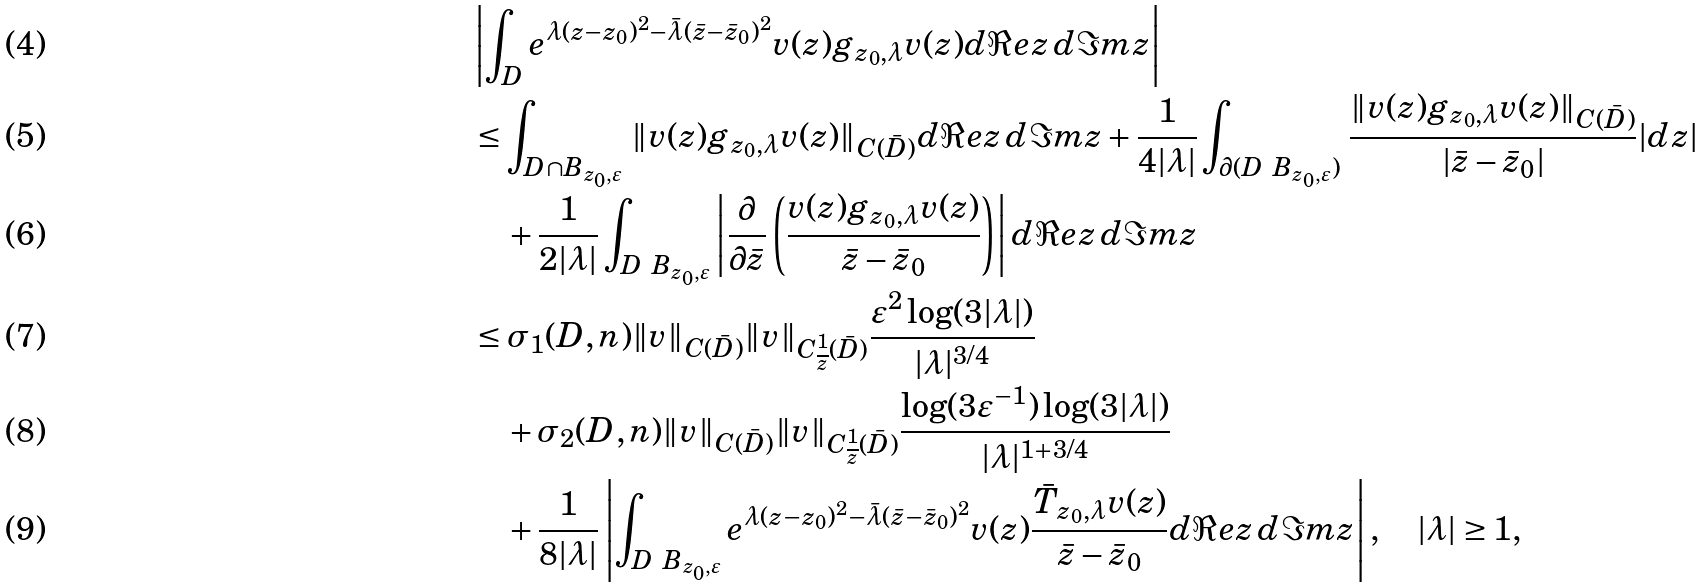<formula> <loc_0><loc_0><loc_500><loc_500>& \left | \int _ { D } e ^ { \lambda ( z - z _ { 0 } ) ^ { 2 } - \bar { \lambda } ( \bar { z } - \bar { z } _ { 0 } ) ^ { 2 } } v ( z ) g _ { z _ { 0 } , \lambda } v ( z ) d \Re e z \, d \Im m z \right | \\ & \leq \int _ { D \cap B _ { z _ { 0 } , \varepsilon } } \, \| v ( z ) g _ { z _ { 0 } , \lambda } v ( z ) \| _ { C ( \bar { D } ) } d \Re e z \, d \Im m z + \frac { 1 } { 4 | \lambda | } \int _ { \partial ( D \ B _ { z _ { 0 } , \varepsilon } ) } \, \frac { \| v ( z ) g _ { z _ { 0 } , \lambda } v ( z ) \| _ { C ( \bar { D } ) } } { | \bar { z } - \bar { z } _ { 0 } | } | d z | \\ & \quad + \frac { 1 } { 2 | \lambda | } \int _ { D \ B _ { z _ { 0 } , \varepsilon } } \left | \frac { \partial } { \partial \bar { z } } \left ( \frac { v ( z ) g _ { z _ { 0 } , \lambda } v ( z ) } { \bar { z } - \bar { z } _ { 0 } } \right ) \right | d \Re e z \, d \Im m z \\ & \leq \sigma _ { 1 } ( D , n ) \| v \| _ { C ( \bar { D } ) } \| v \| _ { C ^ { 1 } _ { \overline { z } } ( \bar { D } ) } \frac { \varepsilon ^ { 2 } \log ( 3 | \lambda | ) } { | \lambda | ^ { 3 / 4 } } \\ & \quad + \sigma _ { 2 } ( D , n ) \| v \| _ { C ( \bar { D } ) } \| v \| _ { C ^ { 1 } _ { \overline { z } } ( \bar { D } ) } \frac { \log ( 3 \varepsilon ^ { - 1 } ) \log ( 3 | \lambda | ) } { | \lambda | ^ { 1 + 3 / 4 } } \\ & \quad + \frac { 1 } { 8 | \lambda | } \left | \int _ { D \ B _ { z _ { 0 } , \varepsilon } } e ^ { \lambda ( z - z _ { 0 } ) ^ { 2 } - \bar { \lambda } ( \bar { z } - \bar { z } _ { 0 } ) ^ { 2 } } v ( z ) \frac { \bar { T } _ { z _ { 0 } , \lambda } v ( z ) } { \bar { z } - \bar { z } _ { 0 } } d \Re e z \, d \Im m z \right | , \quad | \lambda | \geq 1 ,</formula> 